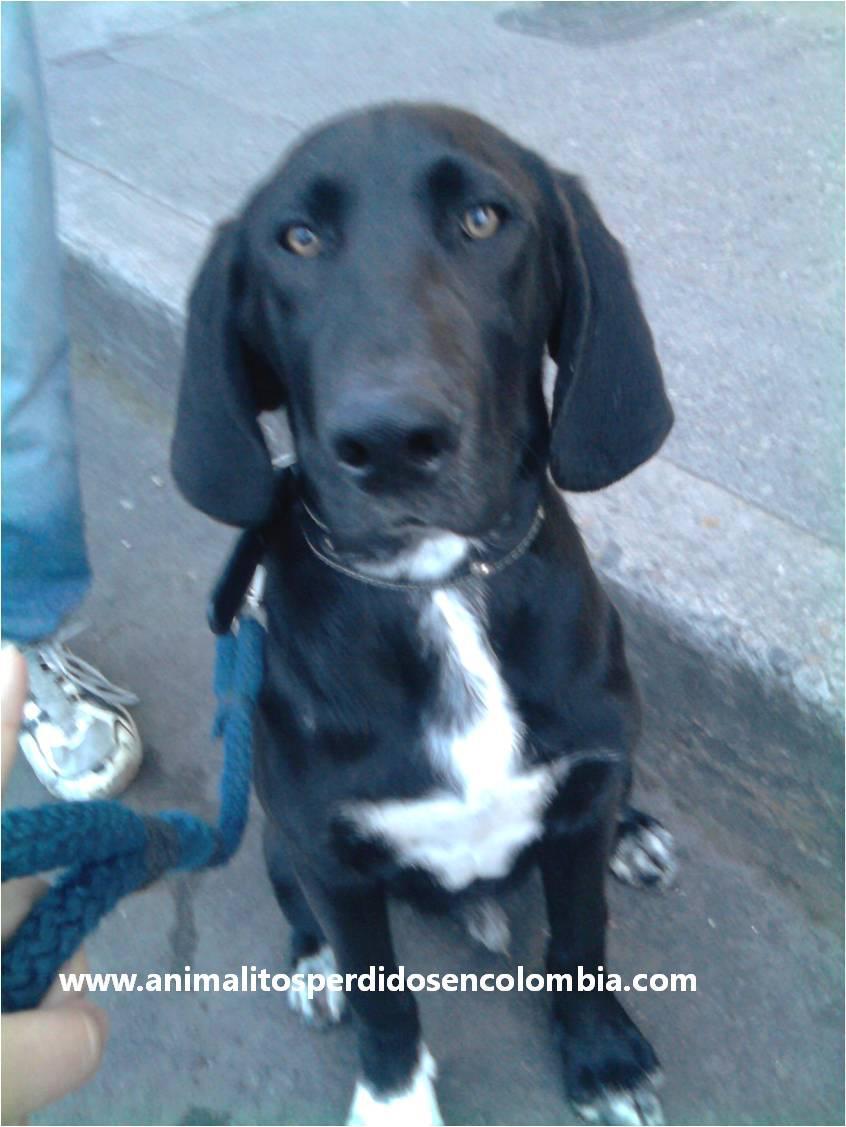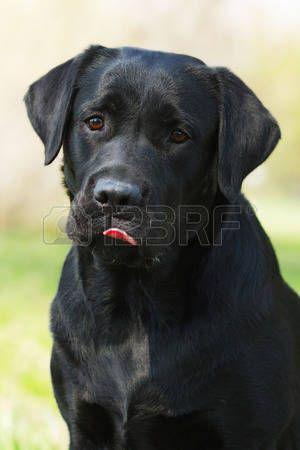The first image is the image on the left, the second image is the image on the right. Considering the images on both sides, is "There is at most 1 Yellow Labrador sitting besides 2 darker Labradors." valid? Answer yes or no. No. 